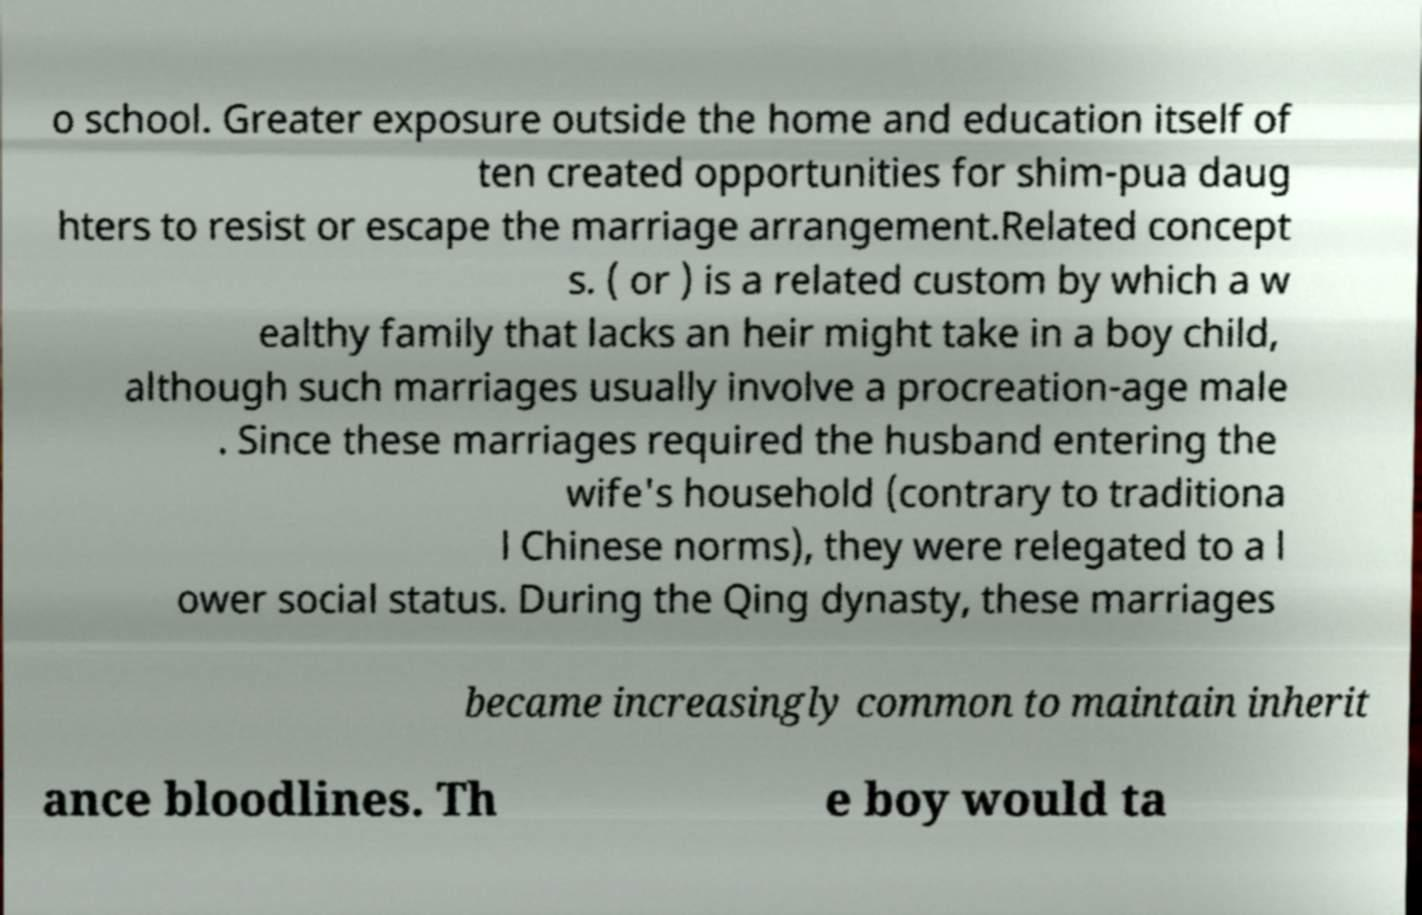There's text embedded in this image that I need extracted. Can you transcribe it verbatim? o school. Greater exposure outside the home and education itself of ten created opportunities for shim-pua daug hters to resist or escape the marriage arrangement.Related concept s. ( or ) is a related custom by which a w ealthy family that lacks an heir might take in a boy child, although such marriages usually involve a procreation-age male . Since these marriages required the husband entering the wife's household (contrary to traditiona l Chinese norms), they were relegated to a l ower social status. During the Qing dynasty, these marriages became increasingly common to maintain inherit ance bloodlines. Th e boy would ta 